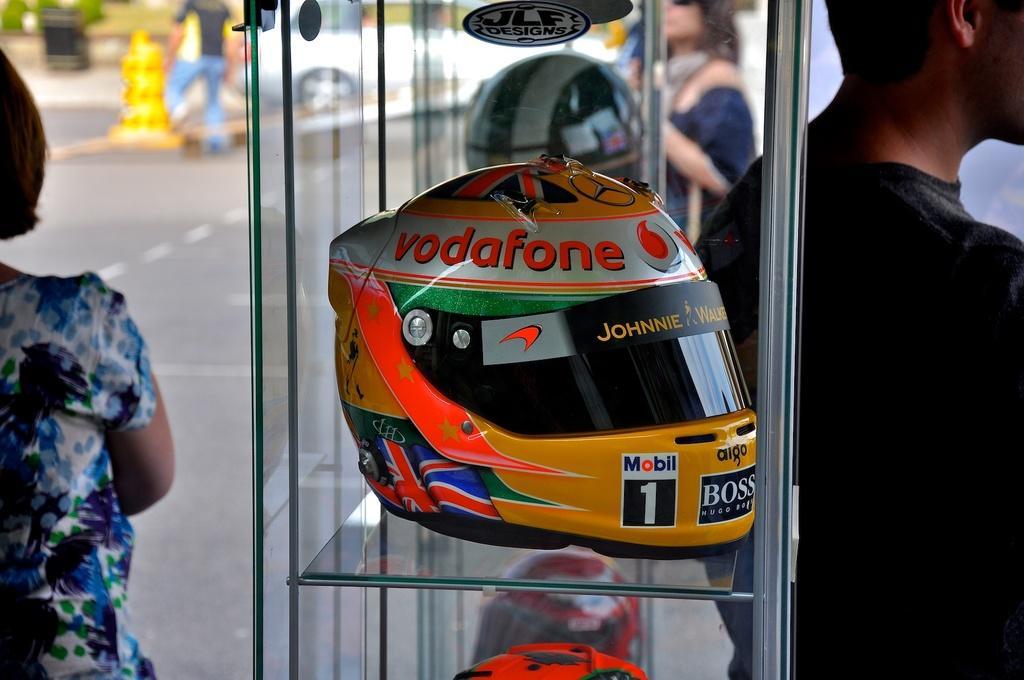In one or two sentences, can you explain what this image depicts? In this image we can see helmets on the glass shelf, we can see a few people, blurred background. 